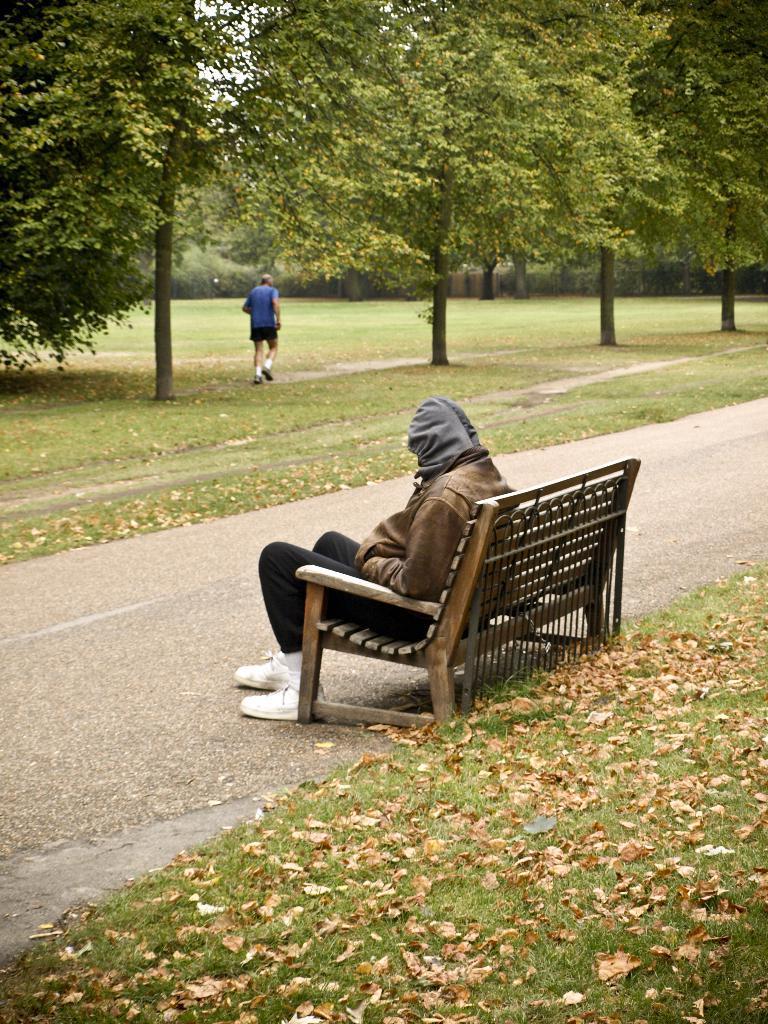In one or two sentences, can you explain what this image depicts? A person is sitting on a bench. Background there are trees, grass and person. On this grass there are dried leaves. 